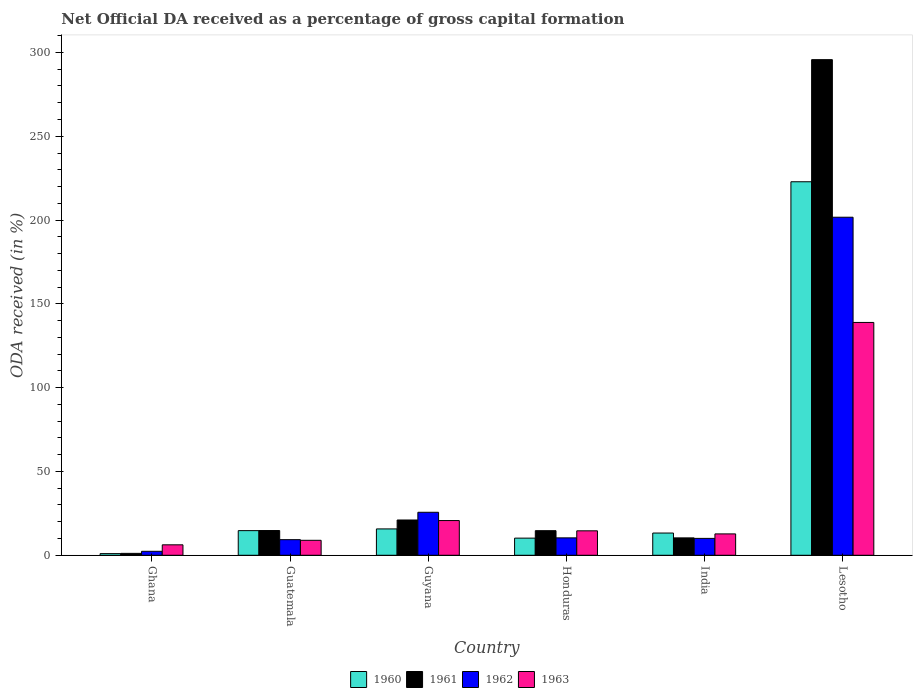How many groups of bars are there?
Keep it short and to the point. 6. Are the number of bars on each tick of the X-axis equal?
Give a very brief answer. Yes. How many bars are there on the 3rd tick from the left?
Your response must be concise. 4. How many bars are there on the 5th tick from the right?
Ensure brevity in your answer.  4. What is the label of the 4th group of bars from the left?
Your answer should be very brief. Honduras. In how many cases, is the number of bars for a given country not equal to the number of legend labels?
Ensure brevity in your answer.  0. What is the net ODA received in 1963 in Guatemala?
Your answer should be very brief. 8.93. Across all countries, what is the maximum net ODA received in 1960?
Provide a short and direct response. 222.86. Across all countries, what is the minimum net ODA received in 1963?
Ensure brevity in your answer.  6.24. In which country was the net ODA received in 1962 maximum?
Offer a terse response. Lesotho. In which country was the net ODA received in 1960 minimum?
Ensure brevity in your answer.  Ghana. What is the total net ODA received in 1963 in the graph?
Provide a succinct answer. 202.15. What is the difference between the net ODA received in 1961 in Ghana and that in Guyana?
Your answer should be compact. -19.91. What is the difference between the net ODA received in 1962 in Lesotho and the net ODA received in 1961 in Ghana?
Offer a terse response. 200.57. What is the average net ODA received in 1962 per country?
Keep it short and to the point. 43.25. What is the difference between the net ODA received of/in 1962 and net ODA received of/in 1963 in Lesotho?
Give a very brief answer. 62.78. What is the ratio of the net ODA received in 1960 in Guatemala to that in Guyana?
Offer a terse response. 0.93. What is the difference between the highest and the second highest net ODA received in 1963?
Your answer should be very brief. 118.2. What is the difference between the highest and the lowest net ODA received in 1961?
Give a very brief answer. 294.58. What does the 4th bar from the left in India represents?
Ensure brevity in your answer.  1963. What does the 2nd bar from the right in Lesotho represents?
Provide a succinct answer. 1962. How many bars are there?
Offer a terse response. 24. How many countries are there in the graph?
Your response must be concise. 6. Does the graph contain any zero values?
Ensure brevity in your answer.  No. How many legend labels are there?
Offer a terse response. 4. How are the legend labels stacked?
Ensure brevity in your answer.  Horizontal. What is the title of the graph?
Provide a short and direct response. Net Official DA received as a percentage of gross capital formation. What is the label or title of the X-axis?
Your response must be concise. Country. What is the label or title of the Y-axis?
Give a very brief answer. ODA received (in %). What is the ODA received (in %) in 1960 in Ghana?
Provide a succinct answer. 0.99. What is the ODA received (in %) in 1961 in Ghana?
Provide a succinct answer. 1.13. What is the ODA received (in %) in 1962 in Ghana?
Ensure brevity in your answer.  2.37. What is the ODA received (in %) in 1963 in Ghana?
Give a very brief answer. 6.24. What is the ODA received (in %) in 1960 in Guatemala?
Give a very brief answer. 14.71. What is the ODA received (in %) in 1961 in Guatemala?
Offer a very short reply. 14.76. What is the ODA received (in %) of 1962 in Guatemala?
Ensure brevity in your answer.  9.31. What is the ODA received (in %) of 1963 in Guatemala?
Your answer should be very brief. 8.93. What is the ODA received (in %) of 1960 in Guyana?
Your answer should be compact. 15.73. What is the ODA received (in %) of 1961 in Guyana?
Keep it short and to the point. 21.05. What is the ODA received (in %) in 1962 in Guyana?
Ensure brevity in your answer.  25.65. What is the ODA received (in %) in 1963 in Guyana?
Keep it short and to the point. 20.71. What is the ODA received (in %) of 1960 in Honduras?
Provide a short and direct response. 10.23. What is the ODA received (in %) of 1961 in Honduras?
Offer a very short reply. 14.68. What is the ODA received (in %) in 1962 in Honduras?
Keep it short and to the point. 10.39. What is the ODA received (in %) of 1963 in Honduras?
Your answer should be very brief. 14.59. What is the ODA received (in %) of 1960 in India?
Your response must be concise. 13.27. What is the ODA received (in %) in 1961 in India?
Your response must be concise. 10.37. What is the ODA received (in %) of 1962 in India?
Your answer should be compact. 10.08. What is the ODA received (in %) in 1963 in India?
Offer a terse response. 12.76. What is the ODA received (in %) of 1960 in Lesotho?
Keep it short and to the point. 222.86. What is the ODA received (in %) of 1961 in Lesotho?
Your response must be concise. 295.71. What is the ODA received (in %) of 1962 in Lesotho?
Ensure brevity in your answer.  201.7. What is the ODA received (in %) in 1963 in Lesotho?
Your response must be concise. 138.92. Across all countries, what is the maximum ODA received (in %) of 1960?
Your answer should be compact. 222.86. Across all countries, what is the maximum ODA received (in %) in 1961?
Ensure brevity in your answer.  295.71. Across all countries, what is the maximum ODA received (in %) of 1962?
Ensure brevity in your answer.  201.7. Across all countries, what is the maximum ODA received (in %) of 1963?
Offer a very short reply. 138.92. Across all countries, what is the minimum ODA received (in %) of 1960?
Give a very brief answer. 0.99. Across all countries, what is the minimum ODA received (in %) of 1961?
Offer a terse response. 1.13. Across all countries, what is the minimum ODA received (in %) in 1962?
Your response must be concise. 2.37. Across all countries, what is the minimum ODA received (in %) in 1963?
Offer a very short reply. 6.24. What is the total ODA received (in %) of 1960 in the graph?
Offer a terse response. 277.78. What is the total ODA received (in %) of 1961 in the graph?
Keep it short and to the point. 357.71. What is the total ODA received (in %) of 1962 in the graph?
Your answer should be very brief. 259.51. What is the total ODA received (in %) of 1963 in the graph?
Your response must be concise. 202.15. What is the difference between the ODA received (in %) in 1960 in Ghana and that in Guatemala?
Ensure brevity in your answer.  -13.72. What is the difference between the ODA received (in %) of 1961 in Ghana and that in Guatemala?
Offer a terse response. -13.63. What is the difference between the ODA received (in %) in 1962 in Ghana and that in Guatemala?
Keep it short and to the point. -6.94. What is the difference between the ODA received (in %) of 1963 in Ghana and that in Guatemala?
Your response must be concise. -2.69. What is the difference between the ODA received (in %) of 1960 in Ghana and that in Guyana?
Your response must be concise. -14.74. What is the difference between the ODA received (in %) in 1961 in Ghana and that in Guyana?
Keep it short and to the point. -19.91. What is the difference between the ODA received (in %) in 1962 in Ghana and that in Guyana?
Give a very brief answer. -23.28. What is the difference between the ODA received (in %) in 1963 in Ghana and that in Guyana?
Ensure brevity in your answer.  -14.47. What is the difference between the ODA received (in %) of 1960 in Ghana and that in Honduras?
Offer a very short reply. -9.23. What is the difference between the ODA received (in %) in 1961 in Ghana and that in Honduras?
Make the answer very short. -13.54. What is the difference between the ODA received (in %) in 1962 in Ghana and that in Honduras?
Give a very brief answer. -8.02. What is the difference between the ODA received (in %) in 1963 in Ghana and that in Honduras?
Provide a succinct answer. -8.35. What is the difference between the ODA received (in %) in 1960 in Ghana and that in India?
Make the answer very short. -12.28. What is the difference between the ODA received (in %) in 1961 in Ghana and that in India?
Ensure brevity in your answer.  -9.24. What is the difference between the ODA received (in %) of 1962 in Ghana and that in India?
Make the answer very short. -7.71. What is the difference between the ODA received (in %) in 1963 in Ghana and that in India?
Ensure brevity in your answer.  -6.51. What is the difference between the ODA received (in %) of 1960 in Ghana and that in Lesotho?
Give a very brief answer. -221.87. What is the difference between the ODA received (in %) of 1961 in Ghana and that in Lesotho?
Offer a terse response. -294.58. What is the difference between the ODA received (in %) in 1962 in Ghana and that in Lesotho?
Give a very brief answer. -199.33. What is the difference between the ODA received (in %) in 1963 in Ghana and that in Lesotho?
Offer a very short reply. -132.67. What is the difference between the ODA received (in %) in 1960 in Guatemala and that in Guyana?
Offer a very short reply. -1.02. What is the difference between the ODA received (in %) in 1961 in Guatemala and that in Guyana?
Provide a short and direct response. -6.29. What is the difference between the ODA received (in %) in 1962 in Guatemala and that in Guyana?
Make the answer very short. -16.34. What is the difference between the ODA received (in %) of 1963 in Guatemala and that in Guyana?
Give a very brief answer. -11.78. What is the difference between the ODA received (in %) in 1960 in Guatemala and that in Honduras?
Provide a succinct answer. 4.48. What is the difference between the ODA received (in %) of 1961 in Guatemala and that in Honduras?
Keep it short and to the point. 0.08. What is the difference between the ODA received (in %) of 1962 in Guatemala and that in Honduras?
Ensure brevity in your answer.  -1.08. What is the difference between the ODA received (in %) in 1963 in Guatemala and that in Honduras?
Offer a terse response. -5.66. What is the difference between the ODA received (in %) in 1960 in Guatemala and that in India?
Provide a short and direct response. 1.44. What is the difference between the ODA received (in %) in 1961 in Guatemala and that in India?
Offer a terse response. 4.39. What is the difference between the ODA received (in %) of 1962 in Guatemala and that in India?
Your answer should be compact. -0.77. What is the difference between the ODA received (in %) of 1963 in Guatemala and that in India?
Provide a short and direct response. -3.82. What is the difference between the ODA received (in %) in 1960 in Guatemala and that in Lesotho?
Make the answer very short. -208.15. What is the difference between the ODA received (in %) in 1961 in Guatemala and that in Lesotho?
Offer a very short reply. -280.95. What is the difference between the ODA received (in %) of 1962 in Guatemala and that in Lesotho?
Your answer should be compact. -192.39. What is the difference between the ODA received (in %) in 1963 in Guatemala and that in Lesotho?
Provide a short and direct response. -129.98. What is the difference between the ODA received (in %) of 1960 in Guyana and that in Honduras?
Offer a very short reply. 5.5. What is the difference between the ODA received (in %) in 1961 in Guyana and that in Honduras?
Offer a terse response. 6.37. What is the difference between the ODA received (in %) of 1962 in Guyana and that in Honduras?
Provide a short and direct response. 15.26. What is the difference between the ODA received (in %) in 1963 in Guyana and that in Honduras?
Provide a succinct answer. 6.12. What is the difference between the ODA received (in %) of 1960 in Guyana and that in India?
Give a very brief answer. 2.46. What is the difference between the ODA received (in %) in 1961 in Guyana and that in India?
Make the answer very short. 10.67. What is the difference between the ODA received (in %) of 1962 in Guyana and that in India?
Offer a terse response. 15.57. What is the difference between the ODA received (in %) in 1963 in Guyana and that in India?
Provide a short and direct response. 7.96. What is the difference between the ODA received (in %) in 1960 in Guyana and that in Lesotho?
Your answer should be very brief. -207.13. What is the difference between the ODA received (in %) in 1961 in Guyana and that in Lesotho?
Offer a terse response. -274.67. What is the difference between the ODA received (in %) of 1962 in Guyana and that in Lesotho?
Offer a terse response. -176.05. What is the difference between the ODA received (in %) of 1963 in Guyana and that in Lesotho?
Provide a succinct answer. -118.2. What is the difference between the ODA received (in %) in 1960 in Honduras and that in India?
Offer a terse response. -3.05. What is the difference between the ODA received (in %) in 1961 in Honduras and that in India?
Your answer should be very brief. 4.3. What is the difference between the ODA received (in %) of 1962 in Honduras and that in India?
Your response must be concise. 0.31. What is the difference between the ODA received (in %) in 1963 in Honduras and that in India?
Ensure brevity in your answer.  1.84. What is the difference between the ODA received (in %) in 1960 in Honduras and that in Lesotho?
Offer a very short reply. -212.63. What is the difference between the ODA received (in %) in 1961 in Honduras and that in Lesotho?
Your answer should be compact. -281.04. What is the difference between the ODA received (in %) in 1962 in Honduras and that in Lesotho?
Offer a terse response. -191.31. What is the difference between the ODA received (in %) in 1963 in Honduras and that in Lesotho?
Your answer should be compact. -124.33. What is the difference between the ODA received (in %) of 1960 in India and that in Lesotho?
Provide a succinct answer. -209.59. What is the difference between the ODA received (in %) of 1961 in India and that in Lesotho?
Provide a succinct answer. -285.34. What is the difference between the ODA received (in %) in 1962 in India and that in Lesotho?
Offer a terse response. -191.62. What is the difference between the ODA received (in %) in 1963 in India and that in Lesotho?
Ensure brevity in your answer.  -126.16. What is the difference between the ODA received (in %) of 1960 in Ghana and the ODA received (in %) of 1961 in Guatemala?
Your response must be concise. -13.77. What is the difference between the ODA received (in %) in 1960 in Ghana and the ODA received (in %) in 1962 in Guatemala?
Make the answer very short. -8.32. What is the difference between the ODA received (in %) of 1960 in Ghana and the ODA received (in %) of 1963 in Guatemala?
Give a very brief answer. -7.94. What is the difference between the ODA received (in %) in 1961 in Ghana and the ODA received (in %) in 1962 in Guatemala?
Keep it short and to the point. -8.18. What is the difference between the ODA received (in %) in 1961 in Ghana and the ODA received (in %) in 1963 in Guatemala?
Offer a terse response. -7.8. What is the difference between the ODA received (in %) of 1962 in Ghana and the ODA received (in %) of 1963 in Guatemala?
Your answer should be compact. -6.56. What is the difference between the ODA received (in %) of 1960 in Ghana and the ODA received (in %) of 1961 in Guyana?
Provide a succinct answer. -20.06. What is the difference between the ODA received (in %) of 1960 in Ghana and the ODA received (in %) of 1962 in Guyana?
Your response must be concise. -24.66. What is the difference between the ODA received (in %) of 1960 in Ghana and the ODA received (in %) of 1963 in Guyana?
Keep it short and to the point. -19.72. What is the difference between the ODA received (in %) of 1961 in Ghana and the ODA received (in %) of 1962 in Guyana?
Give a very brief answer. -24.52. What is the difference between the ODA received (in %) in 1961 in Ghana and the ODA received (in %) in 1963 in Guyana?
Give a very brief answer. -19.58. What is the difference between the ODA received (in %) in 1962 in Ghana and the ODA received (in %) in 1963 in Guyana?
Your response must be concise. -18.34. What is the difference between the ODA received (in %) in 1960 in Ghana and the ODA received (in %) in 1961 in Honduras?
Ensure brevity in your answer.  -13.69. What is the difference between the ODA received (in %) in 1960 in Ghana and the ODA received (in %) in 1962 in Honduras?
Provide a succinct answer. -9.4. What is the difference between the ODA received (in %) of 1960 in Ghana and the ODA received (in %) of 1963 in Honduras?
Your answer should be very brief. -13.6. What is the difference between the ODA received (in %) of 1961 in Ghana and the ODA received (in %) of 1962 in Honduras?
Provide a succinct answer. -9.26. What is the difference between the ODA received (in %) of 1961 in Ghana and the ODA received (in %) of 1963 in Honduras?
Make the answer very short. -13.46. What is the difference between the ODA received (in %) of 1962 in Ghana and the ODA received (in %) of 1963 in Honduras?
Give a very brief answer. -12.22. What is the difference between the ODA received (in %) in 1960 in Ghana and the ODA received (in %) in 1961 in India?
Your answer should be very brief. -9.38. What is the difference between the ODA received (in %) of 1960 in Ghana and the ODA received (in %) of 1962 in India?
Your answer should be compact. -9.09. What is the difference between the ODA received (in %) of 1960 in Ghana and the ODA received (in %) of 1963 in India?
Ensure brevity in your answer.  -11.77. What is the difference between the ODA received (in %) of 1961 in Ghana and the ODA received (in %) of 1962 in India?
Your answer should be very brief. -8.95. What is the difference between the ODA received (in %) in 1961 in Ghana and the ODA received (in %) in 1963 in India?
Make the answer very short. -11.62. What is the difference between the ODA received (in %) of 1962 in Ghana and the ODA received (in %) of 1963 in India?
Provide a succinct answer. -10.39. What is the difference between the ODA received (in %) in 1960 in Ghana and the ODA received (in %) in 1961 in Lesotho?
Give a very brief answer. -294.72. What is the difference between the ODA received (in %) of 1960 in Ghana and the ODA received (in %) of 1962 in Lesotho?
Offer a very short reply. -200.71. What is the difference between the ODA received (in %) in 1960 in Ghana and the ODA received (in %) in 1963 in Lesotho?
Make the answer very short. -137.93. What is the difference between the ODA received (in %) of 1961 in Ghana and the ODA received (in %) of 1962 in Lesotho?
Your answer should be very brief. -200.57. What is the difference between the ODA received (in %) of 1961 in Ghana and the ODA received (in %) of 1963 in Lesotho?
Ensure brevity in your answer.  -137.78. What is the difference between the ODA received (in %) in 1962 in Ghana and the ODA received (in %) in 1963 in Lesotho?
Your answer should be very brief. -136.55. What is the difference between the ODA received (in %) of 1960 in Guatemala and the ODA received (in %) of 1961 in Guyana?
Make the answer very short. -6.34. What is the difference between the ODA received (in %) of 1960 in Guatemala and the ODA received (in %) of 1962 in Guyana?
Make the answer very short. -10.95. What is the difference between the ODA received (in %) of 1960 in Guatemala and the ODA received (in %) of 1963 in Guyana?
Offer a very short reply. -6.01. What is the difference between the ODA received (in %) in 1961 in Guatemala and the ODA received (in %) in 1962 in Guyana?
Provide a short and direct response. -10.89. What is the difference between the ODA received (in %) in 1961 in Guatemala and the ODA received (in %) in 1963 in Guyana?
Keep it short and to the point. -5.95. What is the difference between the ODA received (in %) of 1962 in Guatemala and the ODA received (in %) of 1963 in Guyana?
Make the answer very short. -11.4. What is the difference between the ODA received (in %) of 1960 in Guatemala and the ODA received (in %) of 1961 in Honduras?
Provide a succinct answer. 0.03. What is the difference between the ODA received (in %) in 1960 in Guatemala and the ODA received (in %) in 1962 in Honduras?
Offer a very short reply. 4.32. What is the difference between the ODA received (in %) of 1960 in Guatemala and the ODA received (in %) of 1963 in Honduras?
Provide a succinct answer. 0.12. What is the difference between the ODA received (in %) in 1961 in Guatemala and the ODA received (in %) in 1962 in Honduras?
Your response must be concise. 4.37. What is the difference between the ODA received (in %) of 1961 in Guatemala and the ODA received (in %) of 1963 in Honduras?
Your answer should be compact. 0.17. What is the difference between the ODA received (in %) in 1962 in Guatemala and the ODA received (in %) in 1963 in Honduras?
Offer a terse response. -5.28. What is the difference between the ODA received (in %) in 1960 in Guatemala and the ODA received (in %) in 1961 in India?
Your response must be concise. 4.33. What is the difference between the ODA received (in %) of 1960 in Guatemala and the ODA received (in %) of 1962 in India?
Offer a very short reply. 4.63. What is the difference between the ODA received (in %) of 1960 in Guatemala and the ODA received (in %) of 1963 in India?
Make the answer very short. 1.95. What is the difference between the ODA received (in %) of 1961 in Guatemala and the ODA received (in %) of 1962 in India?
Your answer should be very brief. 4.68. What is the difference between the ODA received (in %) in 1961 in Guatemala and the ODA received (in %) in 1963 in India?
Your answer should be compact. 2. What is the difference between the ODA received (in %) in 1962 in Guatemala and the ODA received (in %) in 1963 in India?
Make the answer very short. -3.44. What is the difference between the ODA received (in %) in 1960 in Guatemala and the ODA received (in %) in 1961 in Lesotho?
Offer a terse response. -281.01. What is the difference between the ODA received (in %) in 1960 in Guatemala and the ODA received (in %) in 1962 in Lesotho?
Your answer should be very brief. -186.99. What is the difference between the ODA received (in %) of 1960 in Guatemala and the ODA received (in %) of 1963 in Lesotho?
Make the answer very short. -124.21. What is the difference between the ODA received (in %) of 1961 in Guatemala and the ODA received (in %) of 1962 in Lesotho?
Give a very brief answer. -186.94. What is the difference between the ODA received (in %) of 1961 in Guatemala and the ODA received (in %) of 1963 in Lesotho?
Make the answer very short. -124.16. What is the difference between the ODA received (in %) of 1962 in Guatemala and the ODA received (in %) of 1963 in Lesotho?
Your answer should be very brief. -129.6. What is the difference between the ODA received (in %) of 1960 in Guyana and the ODA received (in %) of 1961 in Honduras?
Your response must be concise. 1.05. What is the difference between the ODA received (in %) in 1960 in Guyana and the ODA received (in %) in 1962 in Honduras?
Your response must be concise. 5.34. What is the difference between the ODA received (in %) in 1960 in Guyana and the ODA received (in %) in 1963 in Honduras?
Your answer should be very brief. 1.14. What is the difference between the ODA received (in %) of 1961 in Guyana and the ODA received (in %) of 1962 in Honduras?
Give a very brief answer. 10.66. What is the difference between the ODA received (in %) of 1961 in Guyana and the ODA received (in %) of 1963 in Honduras?
Offer a very short reply. 6.46. What is the difference between the ODA received (in %) of 1962 in Guyana and the ODA received (in %) of 1963 in Honduras?
Provide a short and direct response. 11.06. What is the difference between the ODA received (in %) in 1960 in Guyana and the ODA received (in %) in 1961 in India?
Your response must be concise. 5.36. What is the difference between the ODA received (in %) in 1960 in Guyana and the ODA received (in %) in 1962 in India?
Your answer should be compact. 5.65. What is the difference between the ODA received (in %) in 1960 in Guyana and the ODA received (in %) in 1963 in India?
Provide a short and direct response. 2.97. What is the difference between the ODA received (in %) in 1961 in Guyana and the ODA received (in %) in 1962 in India?
Give a very brief answer. 10.97. What is the difference between the ODA received (in %) in 1961 in Guyana and the ODA received (in %) in 1963 in India?
Your response must be concise. 8.29. What is the difference between the ODA received (in %) of 1962 in Guyana and the ODA received (in %) of 1963 in India?
Provide a succinct answer. 12.9. What is the difference between the ODA received (in %) in 1960 in Guyana and the ODA received (in %) in 1961 in Lesotho?
Your response must be concise. -279.98. What is the difference between the ODA received (in %) in 1960 in Guyana and the ODA received (in %) in 1962 in Lesotho?
Your response must be concise. -185.97. What is the difference between the ODA received (in %) in 1960 in Guyana and the ODA received (in %) in 1963 in Lesotho?
Keep it short and to the point. -123.19. What is the difference between the ODA received (in %) in 1961 in Guyana and the ODA received (in %) in 1962 in Lesotho?
Your response must be concise. -180.65. What is the difference between the ODA received (in %) in 1961 in Guyana and the ODA received (in %) in 1963 in Lesotho?
Provide a succinct answer. -117.87. What is the difference between the ODA received (in %) in 1962 in Guyana and the ODA received (in %) in 1963 in Lesotho?
Make the answer very short. -113.26. What is the difference between the ODA received (in %) of 1960 in Honduras and the ODA received (in %) of 1961 in India?
Provide a short and direct response. -0.15. What is the difference between the ODA received (in %) in 1960 in Honduras and the ODA received (in %) in 1962 in India?
Provide a succinct answer. 0.14. What is the difference between the ODA received (in %) of 1960 in Honduras and the ODA received (in %) of 1963 in India?
Offer a very short reply. -2.53. What is the difference between the ODA received (in %) of 1961 in Honduras and the ODA received (in %) of 1962 in India?
Make the answer very short. 4.6. What is the difference between the ODA received (in %) in 1961 in Honduras and the ODA received (in %) in 1963 in India?
Provide a short and direct response. 1.92. What is the difference between the ODA received (in %) in 1962 in Honduras and the ODA received (in %) in 1963 in India?
Offer a very short reply. -2.37. What is the difference between the ODA received (in %) of 1960 in Honduras and the ODA received (in %) of 1961 in Lesotho?
Ensure brevity in your answer.  -285.49. What is the difference between the ODA received (in %) in 1960 in Honduras and the ODA received (in %) in 1962 in Lesotho?
Offer a terse response. -191.48. What is the difference between the ODA received (in %) in 1960 in Honduras and the ODA received (in %) in 1963 in Lesotho?
Give a very brief answer. -128.69. What is the difference between the ODA received (in %) of 1961 in Honduras and the ODA received (in %) of 1962 in Lesotho?
Your response must be concise. -187.02. What is the difference between the ODA received (in %) in 1961 in Honduras and the ODA received (in %) in 1963 in Lesotho?
Offer a very short reply. -124.24. What is the difference between the ODA received (in %) of 1962 in Honduras and the ODA received (in %) of 1963 in Lesotho?
Provide a short and direct response. -128.53. What is the difference between the ODA received (in %) of 1960 in India and the ODA received (in %) of 1961 in Lesotho?
Your answer should be compact. -282.44. What is the difference between the ODA received (in %) in 1960 in India and the ODA received (in %) in 1962 in Lesotho?
Your response must be concise. -188.43. What is the difference between the ODA received (in %) of 1960 in India and the ODA received (in %) of 1963 in Lesotho?
Your response must be concise. -125.65. What is the difference between the ODA received (in %) in 1961 in India and the ODA received (in %) in 1962 in Lesotho?
Your response must be concise. -191.33. What is the difference between the ODA received (in %) in 1961 in India and the ODA received (in %) in 1963 in Lesotho?
Provide a succinct answer. -128.54. What is the difference between the ODA received (in %) of 1962 in India and the ODA received (in %) of 1963 in Lesotho?
Your answer should be compact. -128.84. What is the average ODA received (in %) of 1960 per country?
Make the answer very short. 46.3. What is the average ODA received (in %) of 1961 per country?
Provide a short and direct response. 59.62. What is the average ODA received (in %) of 1962 per country?
Keep it short and to the point. 43.25. What is the average ODA received (in %) in 1963 per country?
Ensure brevity in your answer.  33.69. What is the difference between the ODA received (in %) of 1960 and ODA received (in %) of 1961 in Ghana?
Your response must be concise. -0.14. What is the difference between the ODA received (in %) in 1960 and ODA received (in %) in 1962 in Ghana?
Offer a terse response. -1.38. What is the difference between the ODA received (in %) in 1960 and ODA received (in %) in 1963 in Ghana?
Keep it short and to the point. -5.25. What is the difference between the ODA received (in %) in 1961 and ODA received (in %) in 1962 in Ghana?
Provide a short and direct response. -1.24. What is the difference between the ODA received (in %) of 1961 and ODA received (in %) of 1963 in Ghana?
Provide a short and direct response. -5.11. What is the difference between the ODA received (in %) in 1962 and ODA received (in %) in 1963 in Ghana?
Your answer should be compact. -3.87. What is the difference between the ODA received (in %) in 1960 and ODA received (in %) in 1961 in Guatemala?
Offer a very short reply. -0.05. What is the difference between the ODA received (in %) in 1960 and ODA received (in %) in 1962 in Guatemala?
Keep it short and to the point. 5.39. What is the difference between the ODA received (in %) of 1960 and ODA received (in %) of 1963 in Guatemala?
Keep it short and to the point. 5.77. What is the difference between the ODA received (in %) in 1961 and ODA received (in %) in 1962 in Guatemala?
Your answer should be compact. 5.45. What is the difference between the ODA received (in %) of 1961 and ODA received (in %) of 1963 in Guatemala?
Offer a terse response. 5.83. What is the difference between the ODA received (in %) in 1962 and ODA received (in %) in 1963 in Guatemala?
Offer a very short reply. 0.38. What is the difference between the ODA received (in %) in 1960 and ODA received (in %) in 1961 in Guyana?
Offer a terse response. -5.32. What is the difference between the ODA received (in %) of 1960 and ODA received (in %) of 1962 in Guyana?
Ensure brevity in your answer.  -9.92. What is the difference between the ODA received (in %) in 1960 and ODA received (in %) in 1963 in Guyana?
Your response must be concise. -4.98. What is the difference between the ODA received (in %) of 1961 and ODA received (in %) of 1962 in Guyana?
Ensure brevity in your answer.  -4.61. What is the difference between the ODA received (in %) of 1961 and ODA received (in %) of 1963 in Guyana?
Your answer should be compact. 0.33. What is the difference between the ODA received (in %) in 1962 and ODA received (in %) in 1963 in Guyana?
Ensure brevity in your answer.  4.94. What is the difference between the ODA received (in %) of 1960 and ODA received (in %) of 1961 in Honduras?
Provide a succinct answer. -4.45. What is the difference between the ODA received (in %) of 1960 and ODA received (in %) of 1962 in Honduras?
Make the answer very short. -0.16. What is the difference between the ODA received (in %) in 1960 and ODA received (in %) in 1963 in Honduras?
Give a very brief answer. -4.37. What is the difference between the ODA received (in %) in 1961 and ODA received (in %) in 1962 in Honduras?
Provide a short and direct response. 4.29. What is the difference between the ODA received (in %) in 1961 and ODA received (in %) in 1963 in Honduras?
Ensure brevity in your answer.  0.09. What is the difference between the ODA received (in %) of 1962 and ODA received (in %) of 1963 in Honduras?
Offer a terse response. -4.2. What is the difference between the ODA received (in %) of 1960 and ODA received (in %) of 1961 in India?
Your response must be concise. 2.9. What is the difference between the ODA received (in %) of 1960 and ODA received (in %) of 1962 in India?
Provide a short and direct response. 3.19. What is the difference between the ODA received (in %) of 1960 and ODA received (in %) of 1963 in India?
Provide a short and direct response. 0.52. What is the difference between the ODA received (in %) of 1961 and ODA received (in %) of 1962 in India?
Offer a terse response. 0.29. What is the difference between the ODA received (in %) of 1961 and ODA received (in %) of 1963 in India?
Your answer should be very brief. -2.38. What is the difference between the ODA received (in %) in 1962 and ODA received (in %) in 1963 in India?
Provide a succinct answer. -2.68. What is the difference between the ODA received (in %) of 1960 and ODA received (in %) of 1961 in Lesotho?
Keep it short and to the point. -72.86. What is the difference between the ODA received (in %) of 1960 and ODA received (in %) of 1962 in Lesotho?
Provide a short and direct response. 21.16. What is the difference between the ODA received (in %) in 1960 and ODA received (in %) in 1963 in Lesotho?
Your answer should be very brief. 83.94. What is the difference between the ODA received (in %) in 1961 and ODA received (in %) in 1962 in Lesotho?
Keep it short and to the point. 94.01. What is the difference between the ODA received (in %) in 1961 and ODA received (in %) in 1963 in Lesotho?
Keep it short and to the point. 156.8. What is the difference between the ODA received (in %) of 1962 and ODA received (in %) of 1963 in Lesotho?
Your response must be concise. 62.78. What is the ratio of the ODA received (in %) of 1960 in Ghana to that in Guatemala?
Your response must be concise. 0.07. What is the ratio of the ODA received (in %) in 1961 in Ghana to that in Guatemala?
Provide a succinct answer. 0.08. What is the ratio of the ODA received (in %) in 1962 in Ghana to that in Guatemala?
Give a very brief answer. 0.25. What is the ratio of the ODA received (in %) in 1963 in Ghana to that in Guatemala?
Your answer should be very brief. 0.7. What is the ratio of the ODA received (in %) of 1960 in Ghana to that in Guyana?
Offer a terse response. 0.06. What is the ratio of the ODA received (in %) of 1961 in Ghana to that in Guyana?
Offer a very short reply. 0.05. What is the ratio of the ODA received (in %) in 1962 in Ghana to that in Guyana?
Offer a terse response. 0.09. What is the ratio of the ODA received (in %) in 1963 in Ghana to that in Guyana?
Keep it short and to the point. 0.3. What is the ratio of the ODA received (in %) of 1960 in Ghana to that in Honduras?
Ensure brevity in your answer.  0.1. What is the ratio of the ODA received (in %) of 1961 in Ghana to that in Honduras?
Your response must be concise. 0.08. What is the ratio of the ODA received (in %) in 1962 in Ghana to that in Honduras?
Provide a succinct answer. 0.23. What is the ratio of the ODA received (in %) in 1963 in Ghana to that in Honduras?
Keep it short and to the point. 0.43. What is the ratio of the ODA received (in %) in 1960 in Ghana to that in India?
Make the answer very short. 0.07. What is the ratio of the ODA received (in %) in 1961 in Ghana to that in India?
Provide a short and direct response. 0.11. What is the ratio of the ODA received (in %) in 1962 in Ghana to that in India?
Offer a very short reply. 0.24. What is the ratio of the ODA received (in %) of 1963 in Ghana to that in India?
Make the answer very short. 0.49. What is the ratio of the ODA received (in %) of 1960 in Ghana to that in Lesotho?
Make the answer very short. 0. What is the ratio of the ODA received (in %) of 1961 in Ghana to that in Lesotho?
Make the answer very short. 0. What is the ratio of the ODA received (in %) in 1962 in Ghana to that in Lesotho?
Your response must be concise. 0.01. What is the ratio of the ODA received (in %) of 1963 in Ghana to that in Lesotho?
Your answer should be very brief. 0.04. What is the ratio of the ODA received (in %) of 1960 in Guatemala to that in Guyana?
Your response must be concise. 0.94. What is the ratio of the ODA received (in %) in 1961 in Guatemala to that in Guyana?
Provide a short and direct response. 0.7. What is the ratio of the ODA received (in %) in 1962 in Guatemala to that in Guyana?
Keep it short and to the point. 0.36. What is the ratio of the ODA received (in %) in 1963 in Guatemala to that in Guyana?
Provide a short and direct response. 0.43. What is the ratio of the ODA received (in %) of 1960 in Guatemala to that in Honduras?
Provide a succinct answer. 1.44. What is the ratio of the ODA received (in %) of 1962 in Guatemala to that in Honduras?
Ensure brevity in your answer.  0.9. What is the ratio of the ODA received (in %) in 1963 in Guatemala to that in Honduras?
Provide a succinct answer. 0.61. What is the ratio of the ODA received (in %) in 1960 in Guatemala to that in India?
Give a very brief answer. 1.11. What is the ratio of the ODA received (in %) in 1961 in Guatemala to that in India?
Keep it short and to the point. 1.42. What is the ratio of the ODA received (in %) of 1962 in Guatemala to that in India?
Give a very brief answer. 0.92. What is the ratio of the ODA received (in %) of 1963 in Guatemala to that in India?
Offer a very short reply. 0.7. What is the ratio of the ODA received (in %) in 1960 in Guatemala to that in Lesotho?
Your answer should be compact. 0.07. What is the ratio of the ODA received (in %) of 1961 in Guatemala to that in Lesotho?
Keep it short and to the point. 0.05. What is the ratio of the ODA received (in %) in 1962 in Guatemala to that in Lesotho?
Give a very brief answer. 0.05. What is the ratio of the ODA received (in %) in 1963 in Guatemala to that in Lesotho?
Offer a terse response. 0.06. What is the ratio of the ODA received (in %) in 1960 in Guyana to that in Honduras?
Keep it short and to the point. 1.54. What is the ratio of the ODA received (in %) of 1961 in Guyana to that in Honduras?
Make the answer very short. 1.43. What is the ratio of the ODA received (in %) of 1962 in Guyana to that in Honduras?
Your answer should be compact. 2.47. What is the ratio of the ODA received (in %) in 1963 in Guyana to that in Honduras?
Provide a succinct answer. 1.42. What is the ratio of the ODA received (in %) of 1960 in Guyana to that in India?
Your answer should be compact. 1.19. What is the ratio of the ODA received (in %) in 1961 in Guyana to that in India?
Your answer should be compact. 2.03. What is the ratio of the ODA received (in %) of 1962 in Guyana to that in India?
Your response must be concise. 2.54. What is the ratio of the ODA received (in %) of 1963 in Guyana to that in India?
Offer a very short reply. 1.62. What is the ratio of the ODA received (in %) of 1960 in Guyana to that in Lesotho?
Offer a terse response. 0.07. What is the ratio of the ODA received (in %) in 1961 in Guyana to that in Lesotho?
Make the answer very short. 0.07. What is the ratio of the ODA received (in %) in 1962 in Guyana to that in Lesotho?
Give a very brief answer. 0.13. What is the ratio of the ODA received (in %) in 1963 in Guyana to that in Lesotho?
Offer a terse response. 0.15. What is the ratio of the ODA received (in %) of 1960 in Honduras to that in India?
Offer a terse response. 0.77. What is the ratio of the ODA received (in %) in 1961 in Honduras to that in India?
Your answer should be very brief. 1.41. What is the ratio of the ODA received (in %) in 1962 in Honduras to that in India?
Your answer should be very brief. 1.03. What is the ratio of the ODA received (in %) in 1963 in Honduras to that in India?
Give a very brief answer. 1.14. What is the ratio of the ODA received (in %) of 1960 in Honduras to that in Lesotho?
Offer a terse response. 0.05. What is the ratio of the ODA received (in %) of 1961 in Honduras to that in Lesotho?
Keep it short and to the point. 0.05. What is the ratio of the ODA received (in %) of 1962 in Honduras to that in Lesotho?
Make the answer very short. 0.05. What is the ratio of the ODA received (in %) in 1963 in Honduras to that in Lesotho?
Your response must be concise. 0.1. What is the ratio of the ODA received (in %) of 1960 in India to that in Lesotho?
Offer a very short reply. 0.06. What is the ratio of the ODA received (in %) of 1961 in India to that in Lesotho?
Ensure brevity in your answer.  0.04. What is the ratio of the ODA received (in %) of 1963 in India to that in Lesotho?
Ensure brevity in your answer.  0.09. What is the difference between the highest and the second highest ODA received (in %) in 1960?
Your answer should be compact. 207.13. What is the difference between the highest and the second highest ODA received (in %) of 1961?
Provide a succinct answer. 274.67. What is the difference between the highest and the second highest ODA received (in %) of 1962?
Your answer should be very brief. 176.05. What is the difference between the highest and the second highest ODA received (in %) of 1963?
Keep it short and to the point. 118.2. What is the difference between the highest and the lowest ODA received (in %) in 1960?
Provide a succinct answer. 221.87. What is the difference between the highest and the lowest ODA received (in %) of 1961?
Make the answer very short. 294.58. What is the difference between the highest and the lowest ODA received (in %) in 1962?
Provide a short and direct response. 199.33. What is the difference between the highest and the lowest ODA received (in %) in 1963?
Your response must be concise. 132.67. 